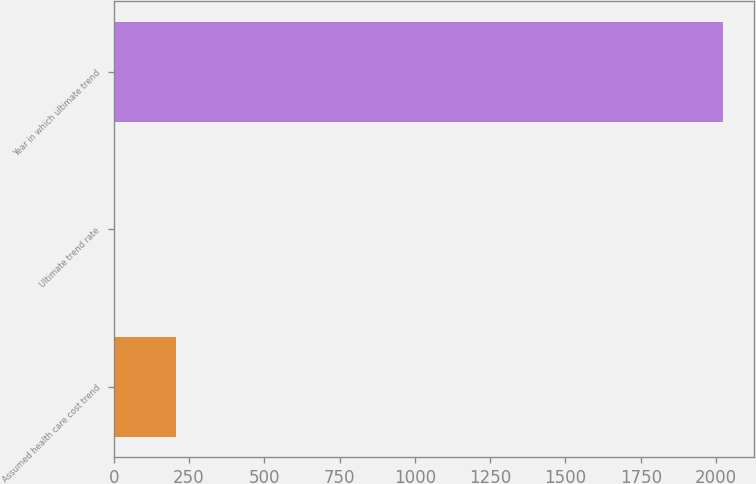Convert chart to OTSL. <chart><loc_0><loc_0><loc_500><loc_500><bar_chart><fcel>Assumed health care cost trend<fcel>Ultimate trend rate<fcel>Year in which ultimate trend<nl><fcel>206.9<fcel>5<fcel>2024<nl></chart> 